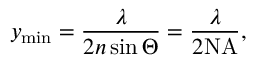Convert formula to latex. <formula><loc_0><loc_0><loc_500><loc_500>y _ { \min } = \frac { \lambda } { 2 n \sin \Theta } = \frac { \lambda } { 2 N A } ,</formula> 